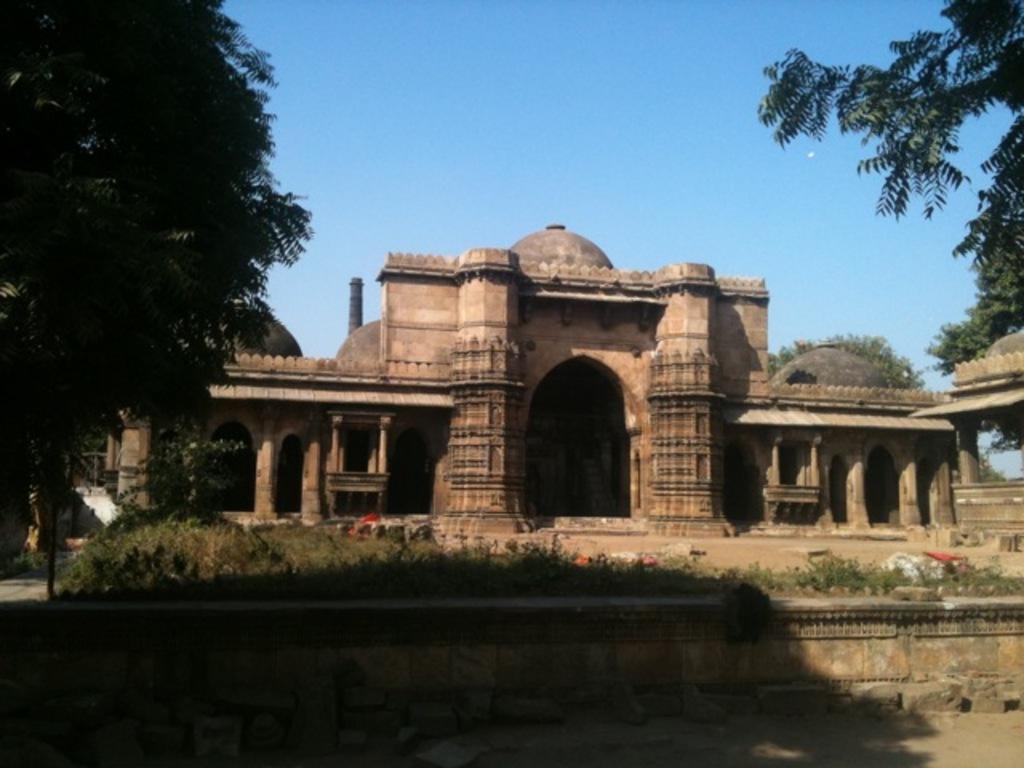Please provide a concise description of this image. In this image I can see a building, few trees and in the front of the building I can see few colourful things on the ground and grass. I can also see the sky in the background and on the bottom side of this image I can see a shadow. 